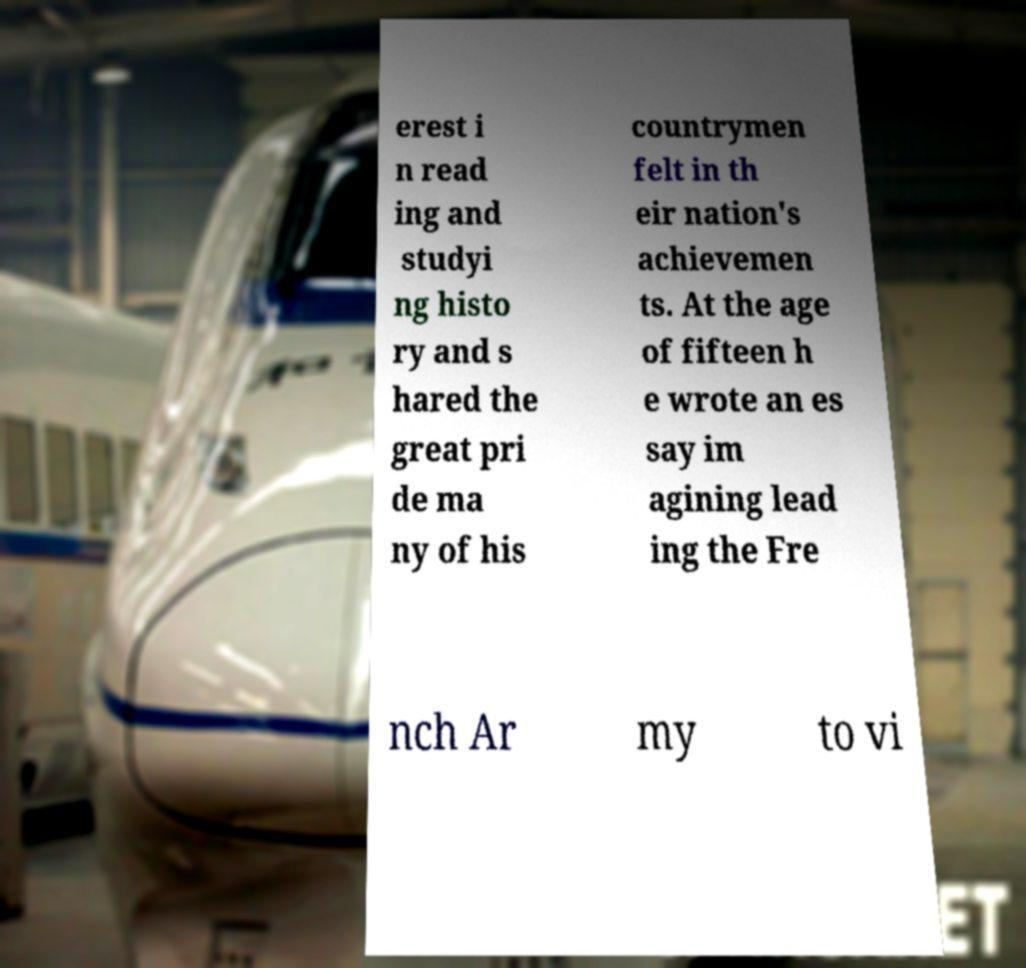I need the written content from this picture converted into text. Can you do that? erest i n read ing and studyi ng histo ry and s hared the great pri de ma ny of his countrymen felt in th eir nation's achievemen ts. At the age of fifteen h e wrote an es say im agining lead ing the Fre nch Ar my to vi 